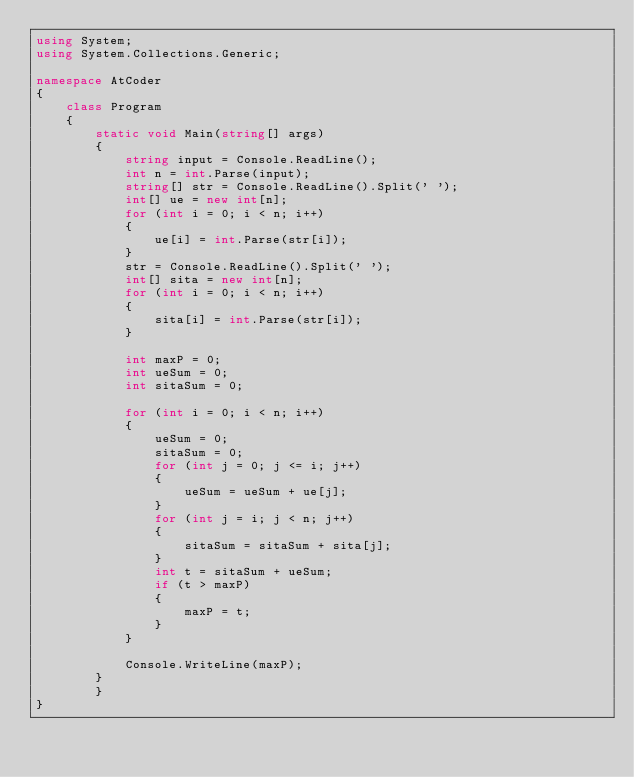Convert code to text. <code><loc_0><loc_0><loc_500><loc_500><_C#_>using System;
using System.Collections.Generic;

namespace AtCoder
{
    class Program
    {
        static void Main(string[] args)
        {
            string input = Console.ReadLine();
            int n = int.Parse(input);
            string[] str = Console.ReadLine().Split(' ');
            int[] ue = new int[n];
            for (int i = 0; i < n; i++)
            {
                ue[i] = int.Parse(str[i]);
            }
            str = Console.ReadLine().Split(' ');
            int[] sita = new int[n];
            for (int i = 0; i < n; i++)
            {
                sita[i] = int.Parse(str[i]);
            }

            int maxP = 0;
            int ueSum = 0;
            int sitaSum = 0;

            for (int i = 0; i < n; i++)
            {
                ueSum = 0;
                sitaSum = 0;
                for (int j = 0; j <= i; j++)
                {
                    ueSum = ueSum + ue[j];
                }
                for (int j = i; j < n; j++)
                {
                    sitaSum = sitaSum + sita[j];
                }
                int t = sitaSum + ueSum;
                if (t > maxP)
                {
                    maxP = t;
                }
            }

            Console.WriteLine(maxP);
        }
        }
}
</code> 